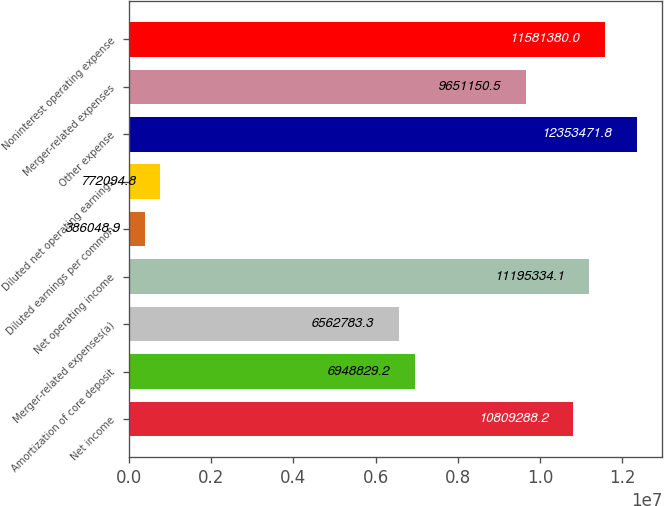Convert chart to OTSL. <chart><loc_0><loc_0><loc_500><loc_500><bar_chart><fcel>Net income<fcel>Amortization of core deposit<fcel>Merger-related expenses(a)<fcel>Net operating income<fcel>Diluted earnings per common<fcel>Diluted net operating earnings<fcel>Other expense<fcel>Merger-related expenses<fcel>Noninterest operating expense<nl><fcel>1.08093e+07<fcel>6.94883e+06<fcel>6.56278e+06<fcel>1.11953e+07<fcel>386049<fcel>772095<fcel>1.23535e+07<fcel>9.65115e+06<fcel>1.15814e+07<nl></chart> 